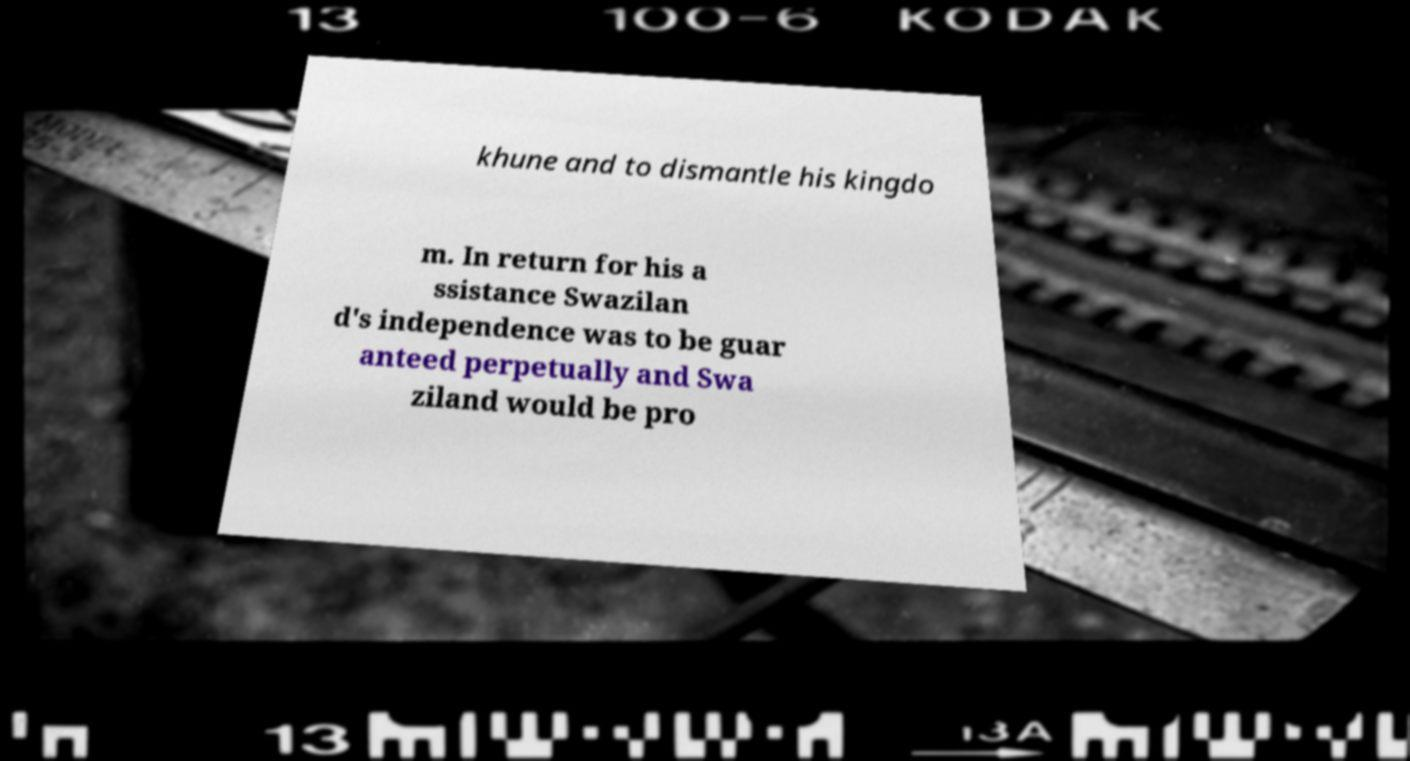Can you accurately transcribe the text from the provided image for me? khune and to dismantle his kingdo m. In return for his a ssistance Swazilan d's independence was to be guar anteed perpetually and Swa ziland would be pro 